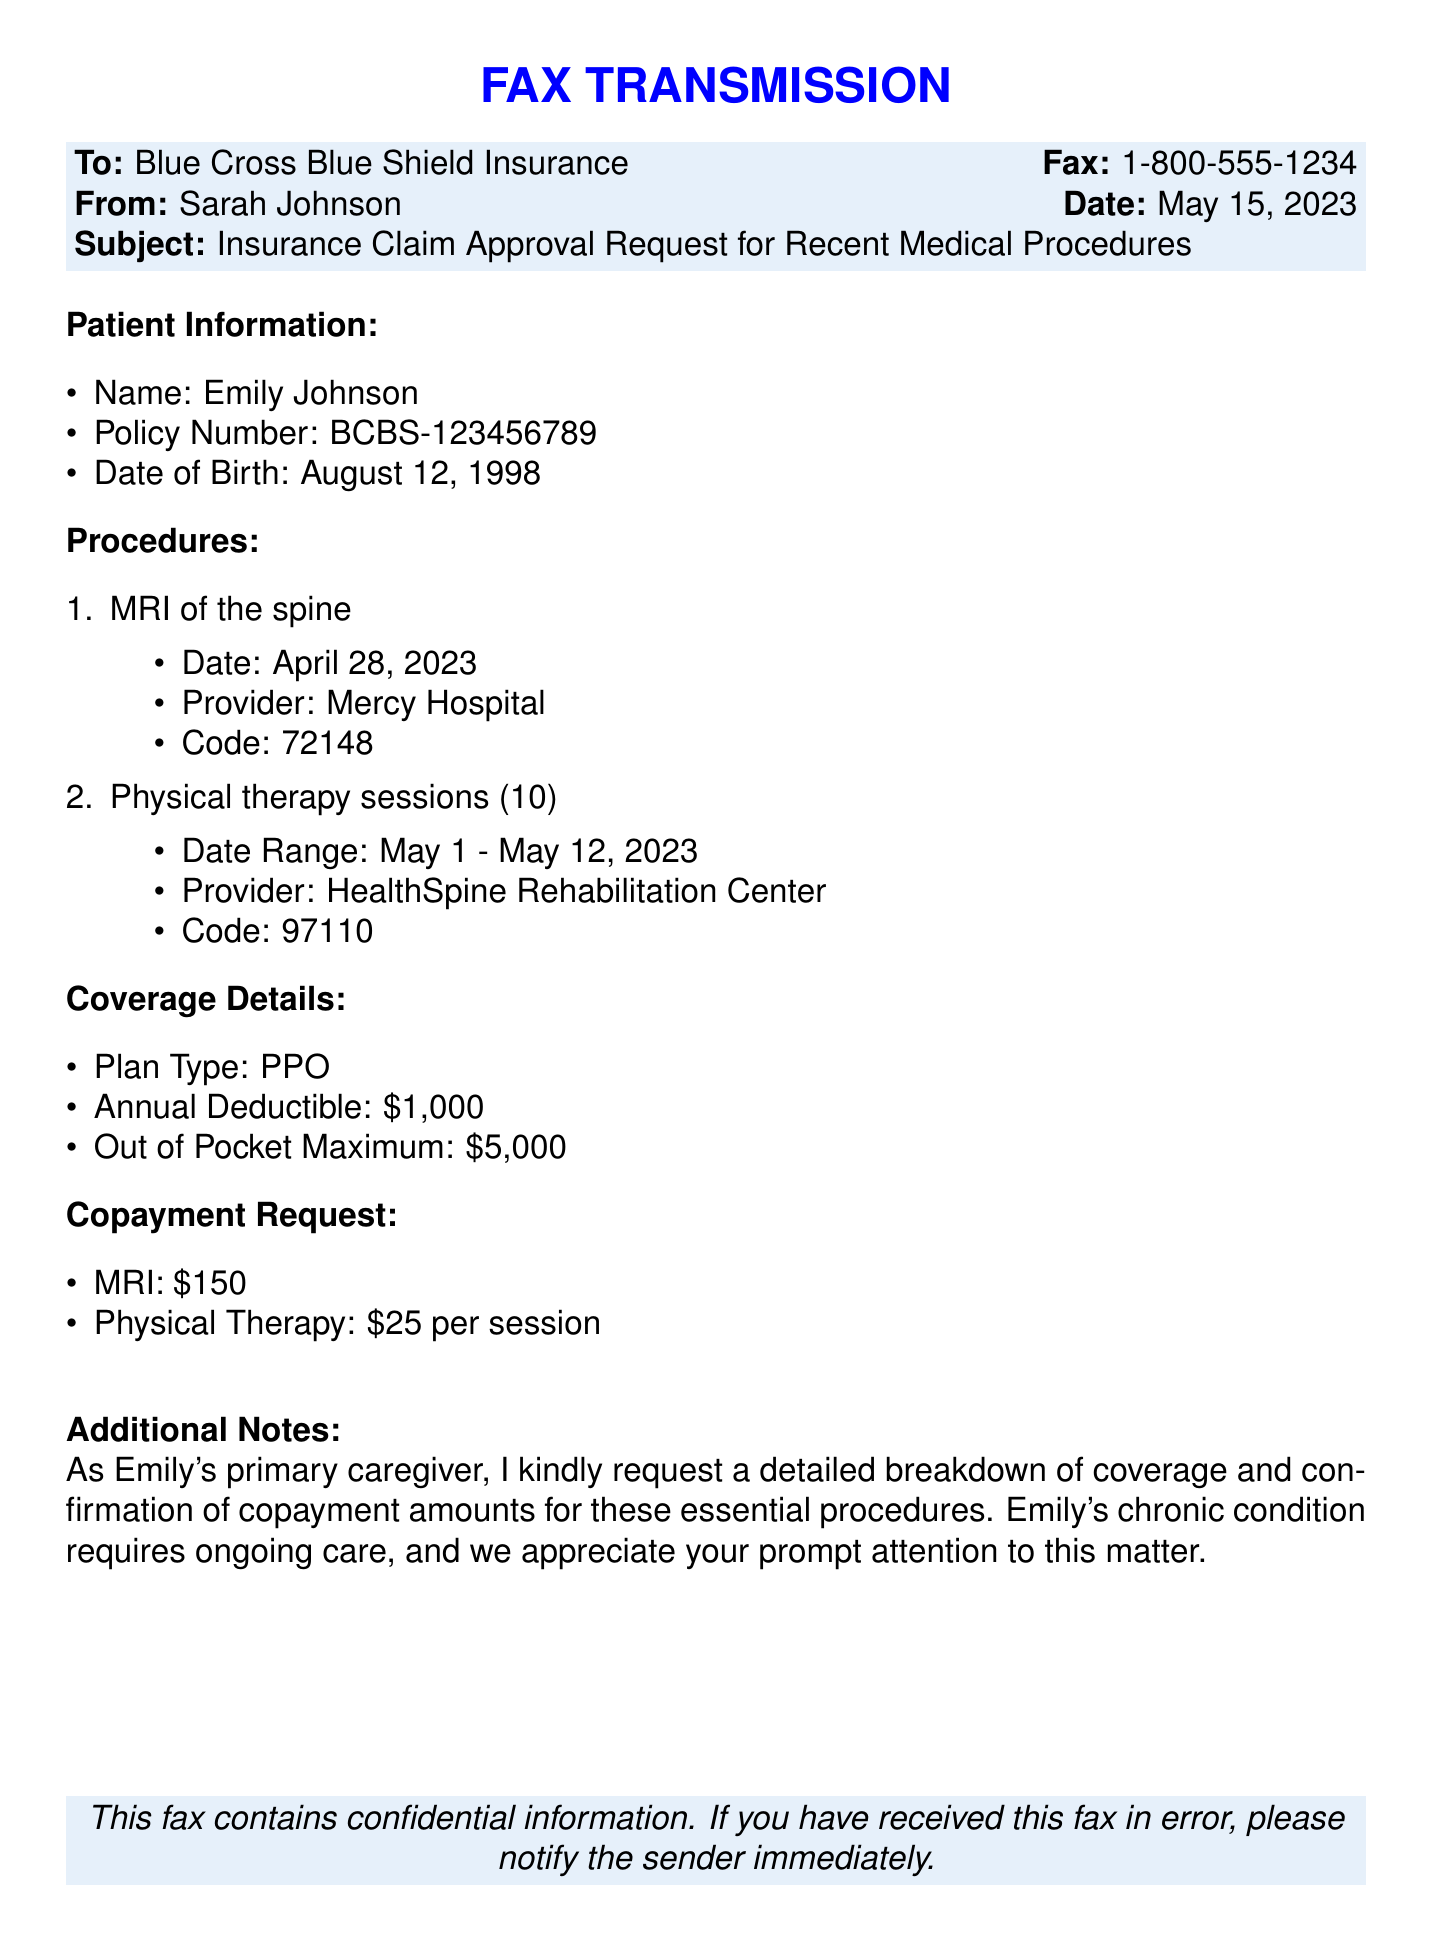What is the date of the MRI procedure? The date of the MRI procedure is specifically mentioned in the document as April 28, 2023.
Answer: April 28, 2023 What is the provider for physical therapy? The provider for the physical therapy sessions is identified in the document as HealthSpine Rehabilitation Center.
Answer: HealthSpine Rehabilitation Center What is the annual deductible amount? The annual deductible amount is provided in the coverage details section of the document as $1,000.
Answer: $1,000 How many physical therapy sessions were required? The document states there were 10 physical therapy sessions requested during the date range given.
Answer: 10 What is the copayment for an MRI? The copayment amount for the MRI is explicitly stated in the document as $150.
Answer: $150 What is the out of pocket maximum for the insurance plan? The out of pocket maximum for the insurance plan is included in the document as $5,000.
Answer: $5,000 What is the subject of the fax? The subject of the fax is clearly mentioned in the document as "Insurance Claim Approval Request for Recent Medical Procedures."
Answer: Insurance Claim Approval Request for Recent Medical Procedures What type of insurance plan does Emily have? The type of insurance plan is indicated in the coverage details as PPO.
Answer: PPO What is the date of birth of the patient? The patient's date of birth is specified in the document as August 12, 1998.
Answer: August 12, 1998 